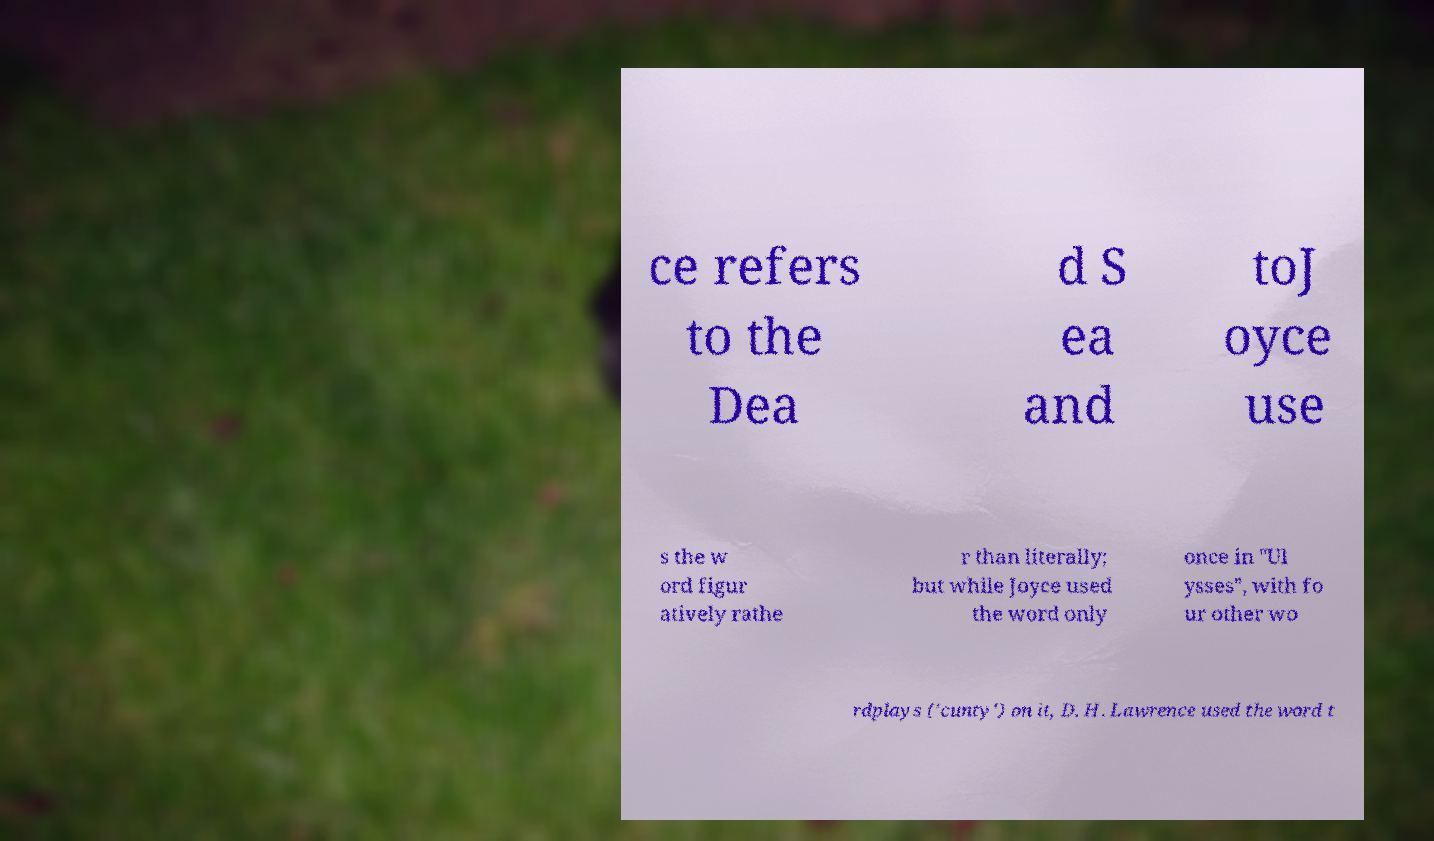Can you accurately transcribe the text from the provided image for me? ce refers to the Dea d S ea and toJ oyce use s the w ord figur atively rathe r than literally; but while Joyce used the word only once in "Ul ysses", with fo ur other wo rdplays ('cunty') on it, D. H. Lawrence used the word t 